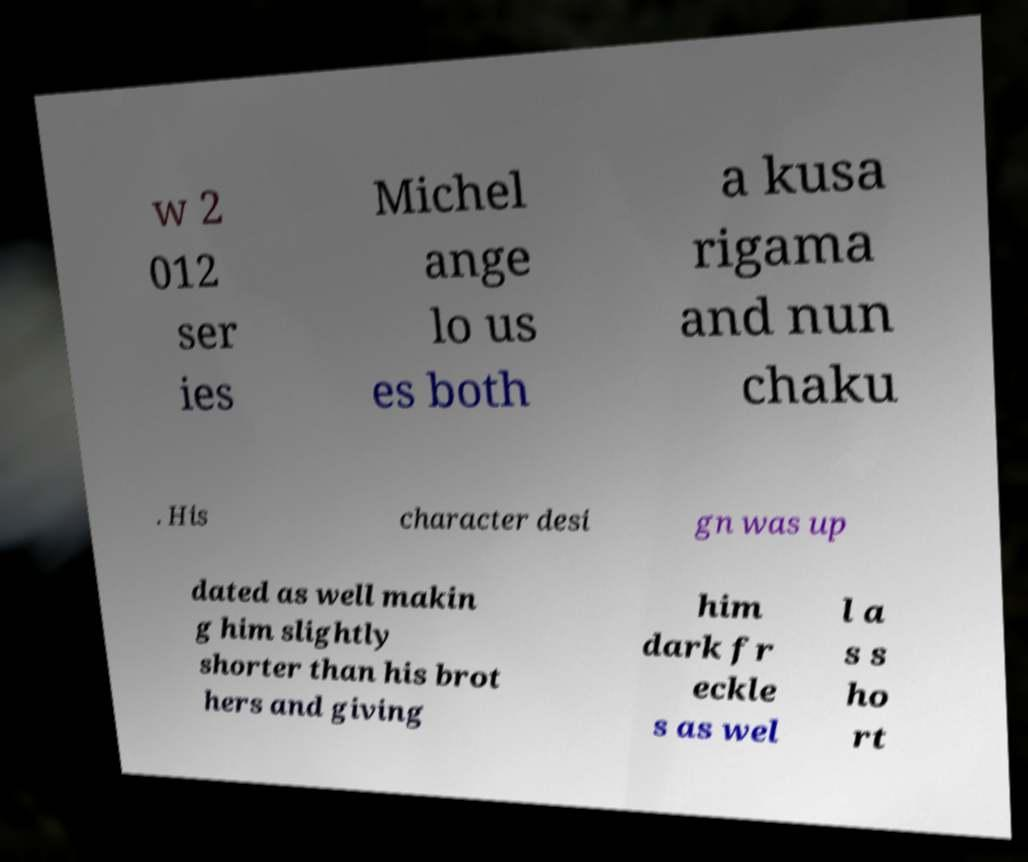Could you extract and type out the text from this image? w 2 012 ser ies Michel ange lo us es both a kusa rigama and nun chaku . His character desi gn was up dated as well makin g him slightly shorter than his brot hers and giving him dark fr eckle s as wel l a s s ho rt 